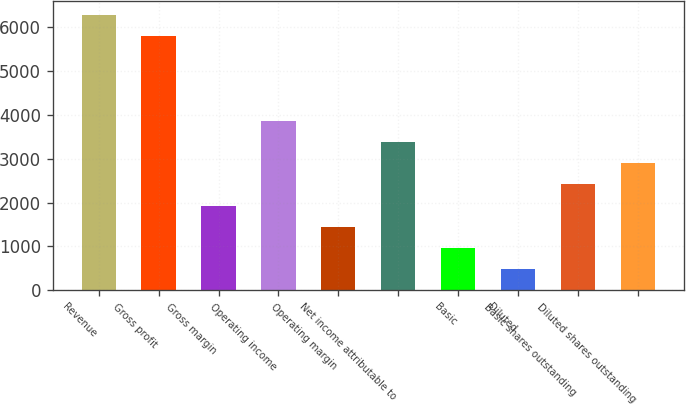Convert chart. <chart><loc_0><loc_0><loc_500><loc_500><bar_chart><fcel>Revenue<fcel>Gross profit<fcel>Gross margin<fcel>Operating income<fcel>Operating margin<fcel>Net income attributable to<fcel>Basic<fcel>Diluted<fcel>Basic shares outstanding<fcel>Diluted shares outstanding<nl><fcel>6282.76<fcel>5799.51<fcel>1933.51<fcel>3866.51<fcel>1450.26<fcel>3383.26<fcel>967.01<fcel>483.76<fcel>2416.76<fcel>2900.01<nl></chart> 